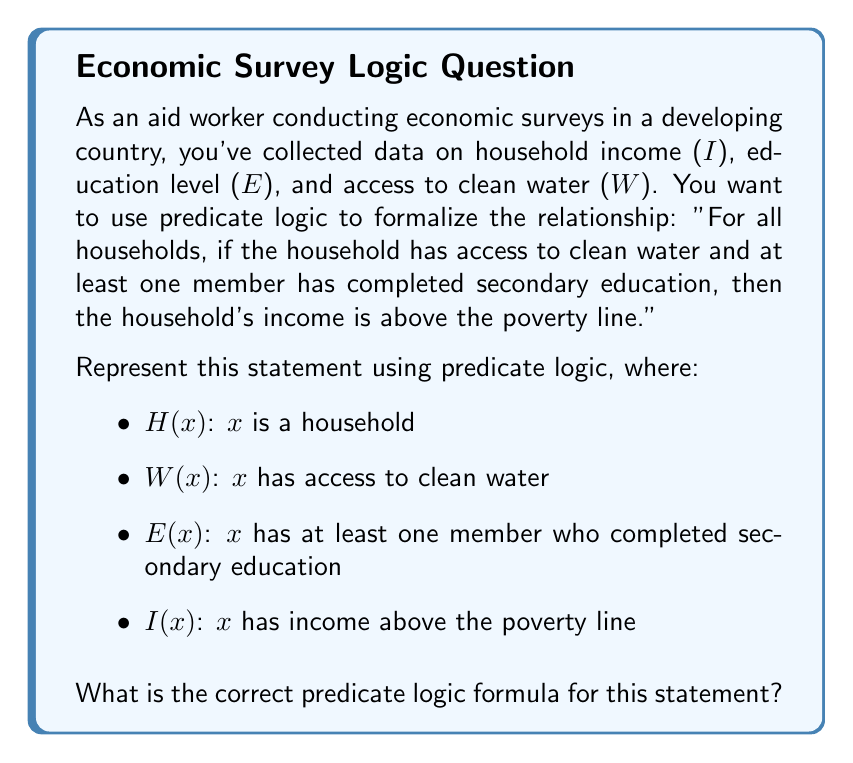Provide a solution to this math problem. Let's break this down step-by-step:

1. We start with "For all households," which is represented by the universal quantifier $\forall x$.

2. We need to specify that x is a household, so we use H(x) as our domain predicate: $\forall x(H(x) \rightarrow ...)$

3. The statement "if the household has access to clean water and at least one member has completed secondary education" forms the antecedent of an implication. This is represented as a conjunction of W(x) and E(x):

   $\forall x(H(x) \rightarrow ((W(x) \land E(x)) \rightarrow ...))$

4. The consequent "then the household's income is above the poverty line" is represented by I(x):

   $\forall x(H(x) \rightarrow ((W(x) \land E(x)) \rightarrow I(x)))$

5. We can simplify this slightly by removing the outer parentheses, as the main connective is the implication:

   $\forall x(H(x) \rightarrow (W(x) \land E(x)) \rightarrow I(x))$

This formula reads as: "For all x, if x is a household, then if x has access to clean water and x has at least one member who completed secondary education, then x has income above the poverty line."
Answer: $\forall x(H(x) \rightarrow (W(x) \land E(x)) \rightarrow I(x))$ 